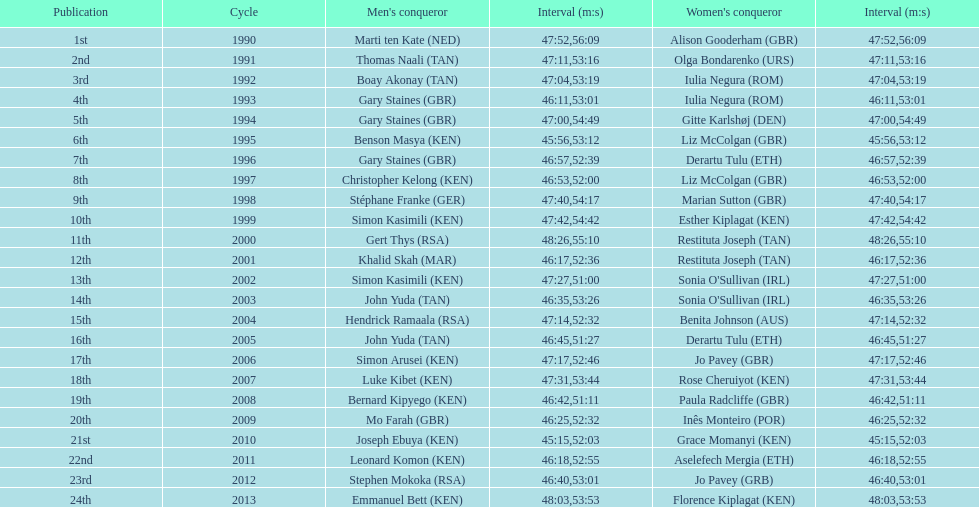What is the number of times, between 1990 and 2013, for britain not to win the men's or women's bupa great south run? 13. 